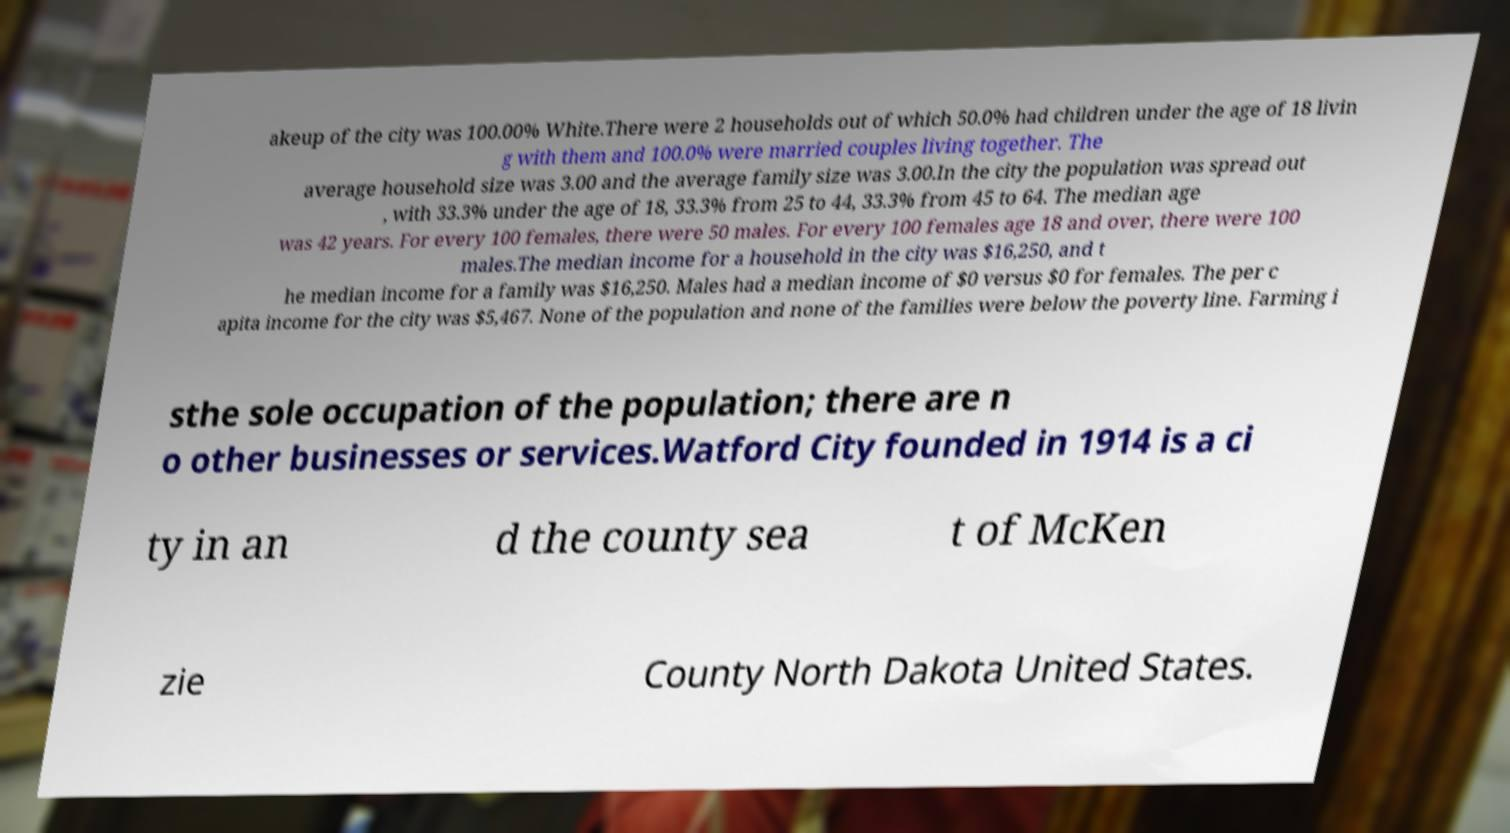There's text embedded in this image that I need extracted. Can you transcribe it verbatim? akeup of the city was 100.00% White.There were 2 households out of which 50.0% had children under the age of 18 livin g with them and 100.0% were married couples living together. The average household size was 3.00 and the average family size was 3.00.In the city the population was spread out , with 33.3% under the age of 18, 33.3% from 25 to 44, 33.3% from 45 to 64. The median age was 42 years. For every 100 females, there were 50 males. For every 100 females age 18 and over, there were 100 males.The median income for a household in the city was $16,250, and t he median income for a family was $16,250. Males had a median income of $0 versus $0 for females. The per c apita income for the city was $5,467. None of the population and none of the families were below the poverty line. Farming i sthe sole occupation of the population; there are n o other businesses or services.Watford City founded in 1914 is a ci ty in an d the county sea t of McKen zie County North Dakota United States. 